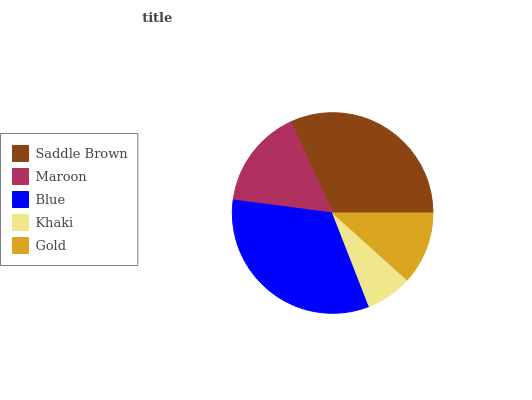Is Khaki the minimum?
Answer yes or no. Yes. Is Blue the maximum?
Answer yes or no. Yes. Is Maroon the minimum?
Answer yes or no. No. Is Maroon the maximum?
Answer yes or no. No. Is Saddle Brown greater than Maroon?
Answer yes or no. Yes. Is Maroon less than Saddle Brown?
Answer yes or no. Yes. Is Maroon greater than Saddle Brown?
Answer yes or no. No. Is Saddle Brown less than Maroon?
Answer yes or no. No. Is Maroon the high median?
Answer yes or no. Yes. Is Maroon the low median?
Answer yes or no. Yes. Is Blue the high median?
Answer yes or no. No. Is Khaki the low median?
Answer yes or no. No. 